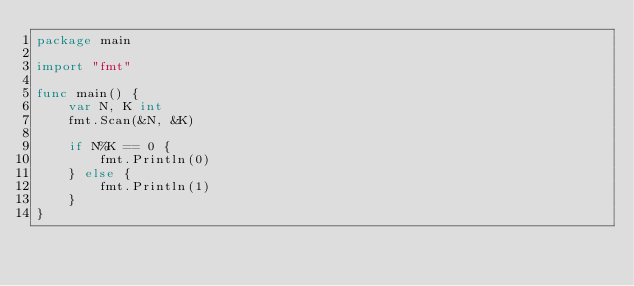Convert code to text. <code><loc_0><loc_0><loc_500><loc_500><_Go_>package main

import "fmt"

func main() {
	var N, K int
	fmt.Scan(&N, &K)

	if N%K == 0 {
		fmt.Println(0)
	} else {
		fmt.Println(1)
	}
}</code> 